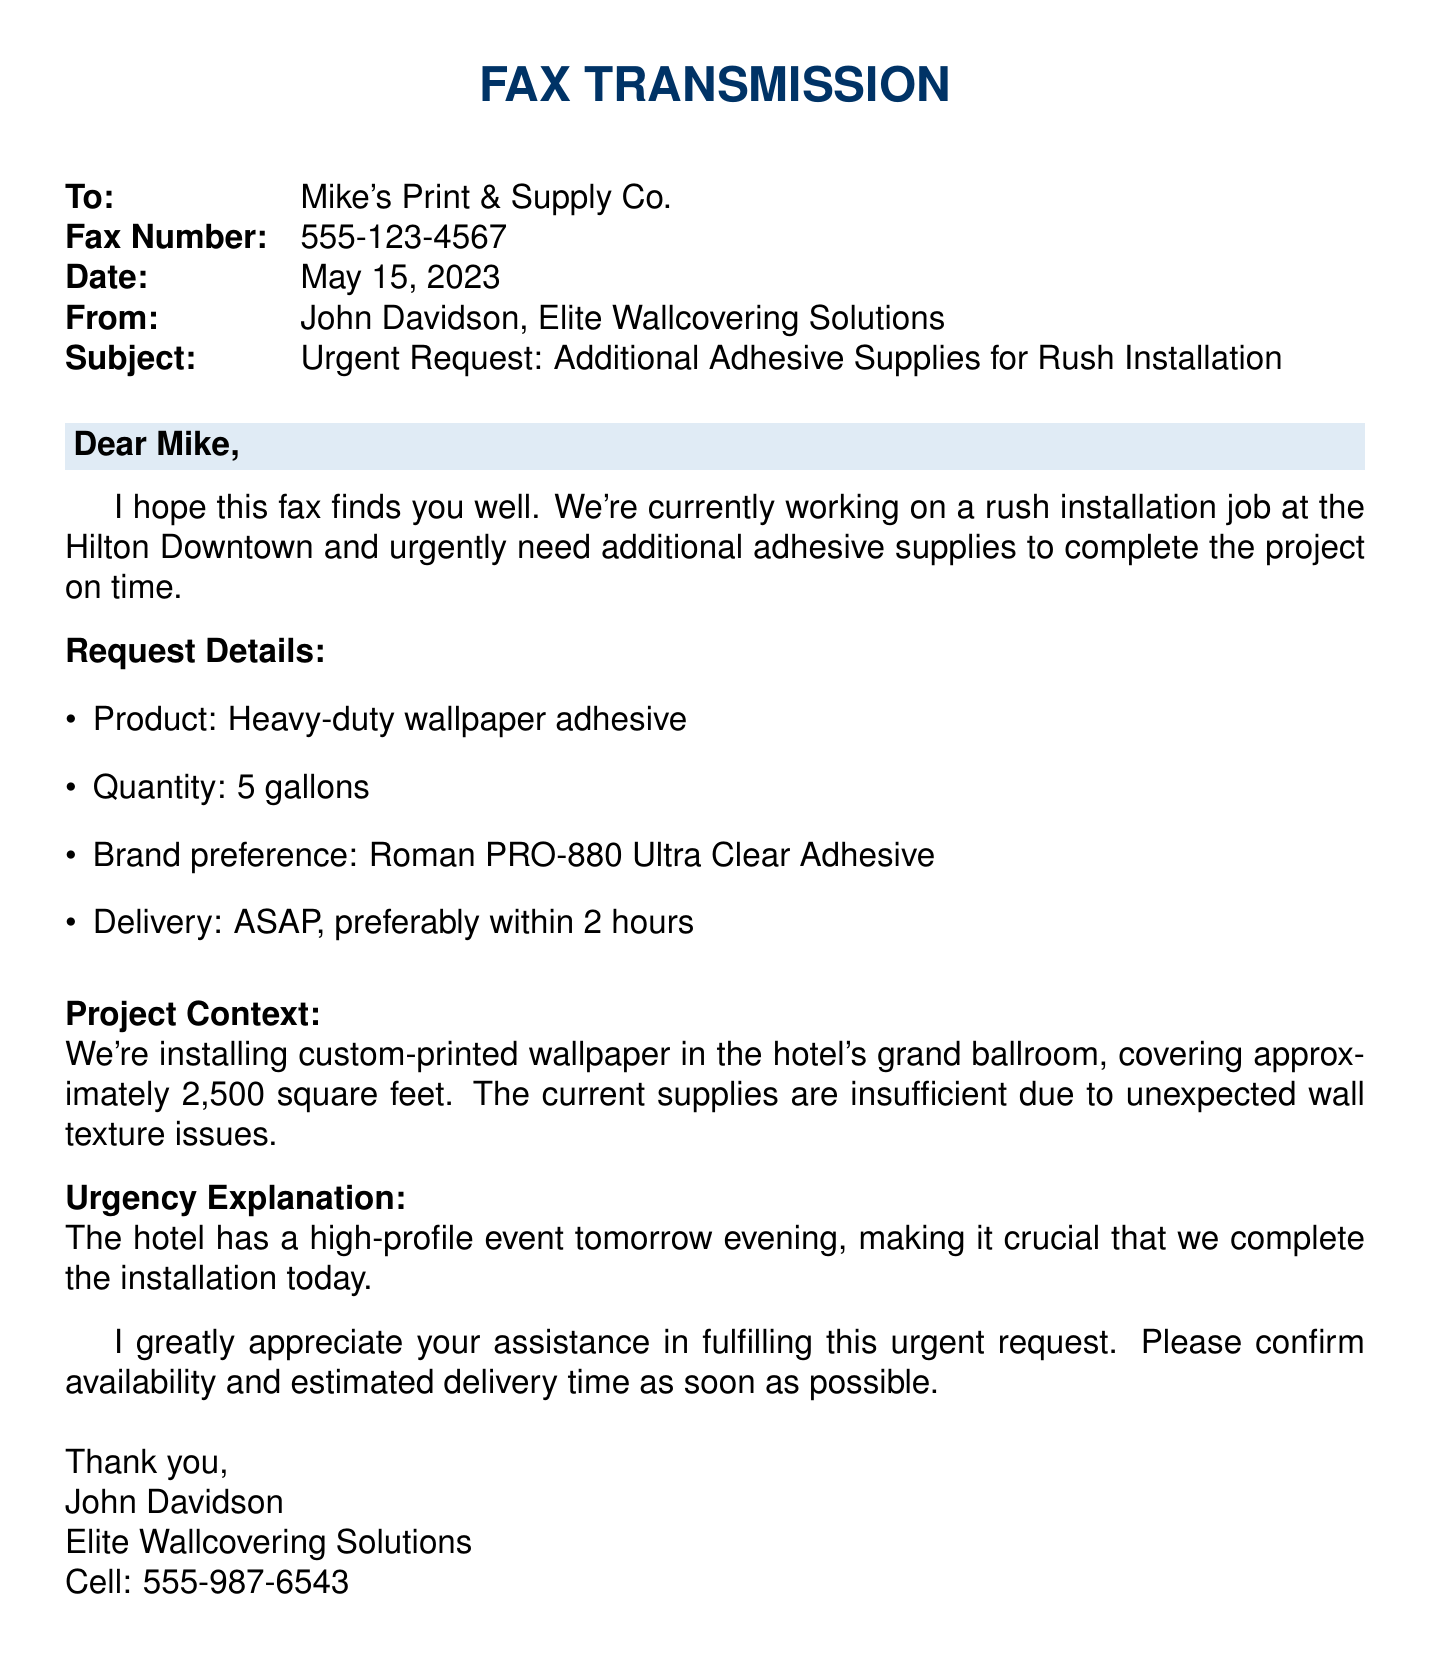what is the recipient's name? The recipient's name is stated in the fax correspondence as the company to which the fax is being sent.
Answer: Mike's Print & Supply Co what is the subject of the fax? The subject is mentioned in the fax header, summarizing the purpose of the document.
Answer: Urgent Request: Additional Adhesive Supplies for Rush Installation what is the quantity of adhesive supplies requested? The quantity is clearly specified in the request details section of the fax.
Answer: 5 gallons what is the preferred brand of adhesive? The preferred brand of adhesive is noted in the request details for clarity on what is needed.
Answer: Roman PRO-880 Ultra Clear Adhesive what is the deadline for delivery? The urgency for delivery is indicated in the request, specifying the desired timeframe.
Answer: ASAP, preferably within 2 hours what is the project context mentioned in the fax? The project context details the location and nature of the job that necessitates the request.
Answer: Installing custom-printed wallpaper in the hotel's grand ballroom who is the sender of the fax? The sender's name and company are provided at the end of the document to identify the author.
Answer: John Davidson, Elite Wallcovering Solutions why is the adhesive needed urgently? The reason for the urgency is tied to a high-profile event scheduled for the next evening, pressing for immediate action.
Answer: High-profile event tomorrow evening how many square feet is being covered by the wallpaper? The size of the installation area is mentioned to provide context for the adhesive request.
Answer: 2,500 square feet 